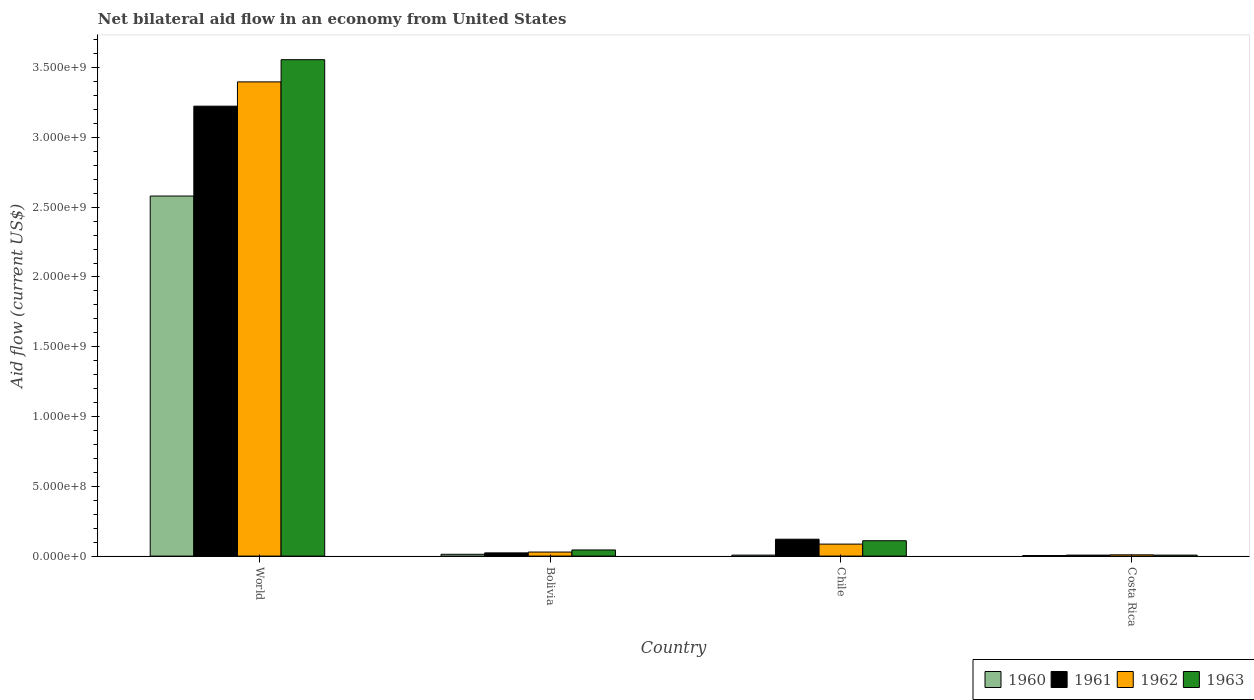How many groups of bars are there?
Provide a short and direct response. 4. Are the number of bars per tick equal to the number of legend labels?
Your response must be concise. Yes. How many bars are there on the 2nd tick from the left?
Your response must be concise. 4. How many bars are there on the 4th tick from the right?
Offer a terse response. 4. What is the net bilateral aid flow in 1960 in World?
Keep it short and to the point. 2.58e+09. Across all countries, what is the maximum net bilateral aid flow in 1960?
Provide a succinct answer. 2.58e+09. Across all countries, what is the minimum net bilateral aid flow in 1960?
Give a very brief answer. 4.00e+06. In which country was the net bilateral aid flow in 1963 maximum?
Keep it short and to the point. World. In which country was the net bilateral aid flow in 1963 minimum?
Your response must be concise. Costa Rica. What is the total net bilateral aid flow in 1961 in the graph?
Give a very brief answer. 3.38e+09. What is the difference between the net bilateral aid flow in 1963 in Bolivia and that in Chile?
Ensure brevity in your answer.  -6.60e+07. What is the difference between the net bilateral aid flow in 1960 in Bolivia and the net bilateral aid flow in 1962 in World?
Your answer should be very brief. -3.38e+09. What is the average net bilateral aid flow in 1961 per country?
Your response must be concise. 8.44e+08. What is the difference between the net bilateral aid flow of/in 1960 and net bilateral aid flow of/in 1961 in Bolivia?
Make the answer very short. -1.00e+07. In how many countries, is the net bilateral aid flow in 1960 greater than 400000000 US$?
Make the answer very short. 1. What is the ratio of the net bilateral aid flow in 1962 in Bolivia to that in World?
Give a very brief answer. 0.01. Is the difference between the net bilateral aid flow in 1960 in Costa Rica and World greater than the difference between the net bilateral aid flow in 1961 in Costa Rica and World?
Your answer should be very brief. Yes. What is the difference between the highest and the second highest net bilateral aid flow in 1960?
Offer a very short reply. 2.57e+09. What is the difference between the highest and the lowest net bilateral aid flow in 1962?
Offer a very short reply. 3.39e+09. How many bars are there?
Offer a very short reply. 16. Are all the bars in the graph horizontal?
Make the answer very short. No. How many countries are there in the graph?
Make the answer very short. 4. Does the graph contain any zero values?
Make the answer very short. No. What is the title of the graph?
Offer a very short reply. Net bilateral aid flow in an economy from United States. Does "1965" appear as one of the legend labels in the graph?
Keep it short and to the point. No. What is the label or title of the Y-axis?
Keep it short and to the point. Aid flow (current US$). What is the Aid flow (current US$) of 1960 in World?
Offer a terse response. 2.58e+09. What is the Aid flow (current US$) in 1961 in World?
Your answer should be very brief. 3.22e+09. What is the Aid flow (current US$) in 1962 in World?
Give a very brief answer. 3.40e+09. What is the Aid flow (current US$) in 1963 in World?
Keep it short and to the point. 3.56e+09. What is the Aid flow (current US$) of 1960 in Bolivia?
Your response must be concise. 1.30e+07. What is the Aid flow (current US$) in 1961 in Bolivia?
Your answer should be compact. 2.30e+07. What is the Aid flow (current US$) in 1962 in Bolivia?
Your answer should be very brief. 2.90e+07. What is the Aid flow (current US$) of 1963 in Bolivia?
Offer a terse response. 4.40e+07. What is the Aid flow (current US$) of 1960 in Chile?
Make the answer very short. 7.00e+06. What is the Aid flow (current US$) in 1961 in Chile?
Your answer should be compact. 1.21e+08. What is the Aid flow (current US$) in 1962 in Chile?
Your answer should be compact. 8.60e+07. What is the Aid flow (current US$) of 1963 in Chile?
Your answer should be very brief. 1.10e+08. What is the Aid flow (current US$) of 1961 in Costa Rica?
Your response must be concise. 7.00e+06. What is the Aid flow (current US$) of 1962 in Costa Rica?
Your answer should be very brief. 9.00e+06. What is the Aid flow (current US$) of 1963 in Costa Rica?
Ensure brevity in your answer.  7.00e+06. Across all countries, what is the maximum Aid flow (current US$) of 1960?
Keep it short and to the point. 2.58e+09. Across all countries, what is the maximum Aid flow (current US$) in 1961?
Make the answer very short. 3.22e+09. Across all countries, what is the maximum Aid flow (current US$) of 1962?
Your answer should be very brief. 3.40e+09. Across all countries, what is the maximum Aid flow (current US$) of 1963?
Make the answer very short. 3.56e+09. Across all countries, what is the minimum Aid flow (current US$) in 1960?
Give a very brief answer. 4.00e+06. Across all countries, what is the minimum Aid flow (current US$) of 1961?
Give a very brief answer. 7.00e+06. Across all countries, what is the minimum Aid flow (current US$) of 1962?
Give a very brief answer. 9.00e+06. Across all countries, what is the minimum Aid flow (current US$) in 1963?
Ensure brevity in your answer.  7.00e+06. What is the total Aid flow (current US$) in 1960 in the graph?
Ensure brevity in your answer.  2.60e+09. What is the total Aid flow (current US$) of 1961 in the graph?
Give a very brief answer. 3.38e+09. What is the total Aid flow (current US$) of 1962 in the graph?
Keep it short and to the point. 3.52e+09. What is the total Aid flow (current US$) in 1963 in the graph?
Your answer should be compact. 3.72e+09. What is the difference between the Aid flow (current US$) of 1960 in World and that in Bolivia?
Make the answer very short. 2.57e+09. What is the difference between the Aid flow (current US$) in 1961 in World and that in Bolivia?
Offer a very short reply. 3.20e+09. What is the difference between the Aid flow (current US$) in 1962 in World and that in Bolivia?
Your answer should be compact. 3.37e+09. What is the difference between the Aid flow (current US$) of 1963 in World and that in Bolivia?
Your response must be concise. 3.51e+09. What is the difference between the Aid flow (current US$) in 1960 in World and that in Chile?
Ensure brevity in your answer.  2.57e+09. What is the difference between the Aid flow (current US$) in 1961 in World and that in Chile?
Keep it short and to the point. 3.10e+09. What is the difference between the Aid flow (current US$) in 1962 in World and that in Chile?
Give a very brief answer. 3.31e+09. What is the difference between the Aid flow (current US$) in 1963 in World and that in Chile?
Offer a terse response. 3.45e+09. What is the difference between the Aid flow (current US$) in 1960 in World and that in Costa Rica?
Provide a short and direct response. 2.58e+09. What is the difference between the Aid flow (current US$) of 1961 in World and that in Costa Rica?
Your answer should be very brief. 3.22e+09. What is the difference between the Aid flow (current US$) of 1962 in World and that in Costa Rica?
Provide a short and direct response. 3.39e+09. What is the difference between the Aid flow (current US$) of 1963 in World and that in Costa Rica?
Ensure brevity in your answer.  3.55e+09. What is the difference between the Aid flow (current US$) of 1960 in Bolivia and that in Chile?
Provide a short and direct response. 6.00e+06. What is the difference between the Aid flow (current US$) of 1961 in Bolivia and that in Chile?
Provide a succinct answer. -9.80e+07. What is the difference between the Aid flow (current US$) in 1962 in Bolivia and that in Chile?
Provide a short and direct response. -5.70e+07. What is the difference between the Aid flow (current US$) in 1963 in Bolivia and that in Chile?
Provide a succinct answer. -6.60e+07. What is the difference between the Aid flow (current US$) in 1960 in Bolivia and that in Costa Rica?
Your response must be concise. 9.00e+06. What is the difference between the Aid flow (current US$) in 1961 in Bolivia and that in Costa Rica?
Provide a short and direct response. 1.60e+07. What is the difference between the Aid flow (current US$) of 1962 in Bolivia and that in Costa Rica?
Provide a short and direct response. 2.00e+07. What is the difference between the Aid flow (current US$) of 1963 in Bolivia and that in Costa Rica?
Your answer should be compact. 3.70e+07. What is the difference between the Aid flow (current US$) of 1960 in Chile and that in Costa Rica?
Make the answer very short. 3.00e+06. What is the difference between the Aid flow (current US$) of 1961 in Chile and that in Costa Rica?
Ensure brevity in your answer.  1.14e+08. What is the difference between the Aid flow (current US$) of 1962 in Chile and that in Costa Rica?
Offer a very short reply. 7.70e+07. What is the difference between the Aid flow (current US$) in 1963 in Chile and that in Costa Rica?
Provide a succinct answer. 1.03e+08. What is the difference between the Aid flow (current US$) in 1960 in World and the Aid flow (current US$) in 1961 in Bolivia?
Ensure brevity in your answer.  2.56e+09. What is the difference between the Aid flow (current US$) in 1960 in World and the Aid flow (current US$) in 1962 in Bolivia?
Give a very brief answer. 2.55e+09. What is the difference between the Aid flow (current US$) in 1960 in World and the Aid flow (current US$) in 1963 in Bolivia?
Offer a very short reply. 2.54e+09. What is the difference between the Aid flow (current US$) in 1961 in World and the Aid flow (current US$) in 1962 in Bolivia?
Make the answer very short. 3.20e+09. What is the difference between the Aid flow (current US$) of 1961 in World and the Aid flow (current US$) of 1963 in Bolivia?
Ensure brevity in your answer.  3.18e+09. What is the difference between the Aid flow (current US$) in 1962 in World and the Aid flow (current US$) in 1963 in Bolivia?
Keep it short and to the point. 3.35e+09. What is the difference between the Aid flow (current US$) of 1960 in World and the Aid flow (current US$) of 1961 in Chile?
Keep it short and to the point. 2.46e+09. What is the difference between the Aid flow (current US$) of 1960 in World and the Aid flow (current US$) of 1962 in Chile?
Provide a succinct answer. 2.49e+09. What is the difference between the Aid flow (current US$) of 1960 in World and the Aid flow (current US$) of 1963 in Chile?
Provide a succinct answer. 2.47e+09. What is the difference between the Aid flow (current US$) of 1961 in World and the Aid flow (current US$) of 1962 in Chile?
Give a very brief answer. 3.14e+09. What is the difference between the Aid flow (current US$) in 1961 in World and the Aid flow (current US$) in 1963 in Chile?
Your answer should be very brief. 3.11e+09. What is the difference between the Aid flow (current US$) in 1962 in World and the Aid flow (current US$) in 1963 in Chile?
Provide a short and direct response. 3.29e+09. What is the difference between the Aid flow (current US$) of 1960 in World and the Aid flow (current US$) of 1961 in Costa Rica?
Ensure brevity in your answer.  2.57e+09. What is the difference between the Aid flow (current US$) of 1960 in World and the Aid flow (current US$) of 1962 in Costa Rica?
Your response must be concise. 2.57e+09. What is the difference between the Aid flow (current US$) in 1960 in World and the Aid flow (current US$) in 1963 in Costa Rica?
Ensure brevity in your answer.  2.57e+09. What is the difference between the Aid flow (current US$) of 1961 in World and the Aid flow (current US$) of 1962 in Costa Rica?
Provide a succinct answer. 3.22e+09. What is the difference between the Aid flow (current US$) of 1961 in World and the Aid flow (current US$) of 1963 in Costa Rica?
Your answer should be very brief. 3.22e+09. What is the difference between the Aid flow (current US$) in 1962 in World and the Aid flow (current US$) in 1963 in Costa Rica?
Offer a very short reply. 3.39e+09. What is the difference between the Aid flow (current US$) in 1960 in Bolivia and the Aid flow (current US$) in 1961 in Chile?
Your answer should be compact. -1.08e+08. What is the difference between the Aid flow (current US$) of 1960 in Bolivia and the Aid flow (current US$) of 1962 in Chile?
Offer a terse response. -7.30e+07. What is the difference between the Aid flow (current US$) of 1960 in Bolivia and the Aid flow (current US$) of 1963 in Chile?
Offer a terse response. -9.70e+07. What is the difference between the Aid flow (current US$) in 1961 in Bolivia and the Aid flow (current US$) in 1962 in Chile?
Keep it short and to the point. -6.30e+07. What is the difference between the Aid flow (current US$) of 1961 in Bolivia and the Aid flow (current US$) of 1963 in Chile?
Your answer should be very brief. -8.70e+07. What is the difference between the Aid flow (current US$) of 1962 in Bolivia and the Aid flow (current US$) of 1963 in Chile?
Your response must be concise. -8.10e+07. What is the difference between the Aid flow (current US$) of 1961 in Bolivia and the Aid flow (current US$) of 1962 in Costa Rica?
Give a very brief answer. 1.40e+07. What is the difference between the Aid flow (current US$) of 1961 in Bolivia and the Aid flow (current US$) of 1963 in Costa Rica?
Make the answer very short. 1.60e+07. What is the difference between the Aid flow (current US$) of 1962 in Bolivia and the Aid flow (current US$) of 1963 in Costa Rica?
Provide a succinct answer. 2.20e+07. What is the difference between the Aid flow (current US$) of 1960 in Chile and the Aid flow (current US$) of 1962 in Costa Rica?
Provide a succinct answer. -2.00e+06. What is the difference between the Aid flow (current US$) in 1961 in Chile and the Aid flow (current US$) in 1962 in Costa Rica?
Offer a terse response. 1.12e+08. What is the difference between the Aid flow (current US$) in 1961 in Chile and the Aid flow (current US$) in 1963 in Costa Rica?
Provide a succinct answer. 1.14e+08. What is the difference between the Aid flow (current US$) in 1962 in Chile and the Aid flow (current US$) in 1963 in Costa Rica?
Your response must be concise. 7.90e+07. What is the average Aid flow (current US$) of 1960 per country?
Ensure brevity in your answer.  6.51e+08. What is the average Aid flow (current US$) in 1961 per country?
Give a very brief answer. 8.44e+08. What is the average Aid flow (current US$) of 1962 per country?
Your answer should be very brief. 8.80e+08. What is the average Aid flow (current US$) in 1963 per country?
Make the answer very short. 9.30e+08. What is the difference between the Aid flow (current US$) of 1960 and Aid flow (current US$) of 1961 in World?
Your response must be concise. -6.44e+08. What is the difference between the Aid flow (current US$) of 1960 and Aid flow (current US$) of 1962 in World?
Provide a short and direct response. -8.18e+08. What is the difference between the Aid flow (current US$) of 1960 and Aid flow (current US$) of 1963 in World?
Give a very brief answer. -9.77e+08. What is the difference between the Aid flow (current US$) in 1961 and Aid flow (current US$) in 1962 in World?
Offer a very short reply. -1.74e+08. What is the difference between the Aid flow (current US$) in 1961 and Aid flow (current US$) in 1963 in World?
Provide a short and direct response. -3.33e+08. What is the difference between the Aid flow (current US$) in 1962 and Aid flow (current US$) in 1963 in World?
Your answer should be compact. -1.59e+08. What is the difference between the Aid flow (current US$) of 1960 and Aid flow (current US$) of 1961 in Bolivia?
Make the answer very short. -1.00e+07. What is the difference between the Aid flow (current US$) in 1960 and Aid flow (current US$) in 1962 in Bolivia?
Give a very brief answer. -1.60e+07. What is the difference between the Aid flow (current US$) of 1960 and Aid flow (current US$) of 1963 in Bolivia?
Make the answer very short. -3.10e+07. What is the difference between the Aid flow (current US$) of 1961 and Aid flow (current US$) of 1962 in Bolivia?
Make the answer very short. -6.00e+06. What is the difference between the Aid flow (current US$) of 1961 and Aid flow (current US$) of 1963 in Bolivia?
Make the answer very short. -2.10e+07. What is the difference between the Aid flow (current US$) of 1962 and Aid flow (current US$) of 1963 in Bolivia?
Offer a very short reply. -1.50e+07. What is the difference between the Aid flow (current US$) of 1960 and Aid flow (current US$) of 1961 in Chile?
Your answer should be compact. -1.14e+08. What is the difference between the Aid flow (current US$) of 1960 and Aid flow (current US$) of 1962 in Chile?
Keep it short and to the point. -7.90e+07. What is the difference between the Aid flow (current US$) in 1960 and Aid flow (current US$) in 1963 in Chile?
Provide a succinct answer. -1.03e+08. What is the difference between the Aid flow (current US$) in 1961 and Aid flow (current US$) in 1962 in Chile?
Your answer should be very brief. 3.50e+07. What is the difference between the Aid flow (current US$) in 1961 and Aid flow (current US$) in 1963 in Chile?
Ensure brevity in your answer.  1.10e+07. What is the difference between the Aid flow (current US$) in 1962 and Aid flow (current US$) in 1963 in Chile?
Provide a succinct answer. -2.40e+07. What is the difference between the Aid flow (current US$) of 1960 and Aid flow (current US$) of 1961 in Costa Rica?
Your response must be concise. -3.00e+06. What is the difference between the Aid flow (current US$) in 1960 and Aid flow (current US$) in 1962 in Costa Rica?
Give a very brief answer. -5.00e+06. What is the difference between the Aid flow (current US$) of 1960 and Aid flow (current US$) of 1963 in Costa Rica?
Your answer should be very brief. -3.00e+06. What is the difference between the Aid flow (current US$) in 1961 and Aid flow (current US$) in 1963 in Costa Rica?
Give a very brief answer. 0. What is the ratio of the Aid flow (current US$) in 1960 in World to that in Bolivia?
Give a very brief answer. 198.46. What is the ratio of the Aid flow (current US$) of 1961 in World to that in Bolivia?
Your answer should be very brief. 140.17. What is the ratio of the Aid flow (current US$) of 1962 in World to that in Bolivia?
Ensure brevity in your answer.  117.17. What is the ratio of the Aid flow (current US$) of 1963 in World to that in Bolivia?
Give a very brief answer. 80.84. What is the ratio of the Aid flow (current US$) of 1960 in World to that in Chile?
Ensure brevity in your answer.  368.57. What is the ratio of the Aid flow (current US$) in 1961 in World to that in Chile?
Offer a very short reply. 26.64. What is the ratio of the Aid flow (current US$) in 1962 in World to that in Chile?
Keep it short and to the point. 39.51. What is the ratio of the Aid flow (current US$) in 1963 in World to that in Chile?
Make the answer very short. 32.34. What is the ratio of the Aid flow (current US$) in 1960 in World to that in Costa Rica?
Provide a succinct answer. 645. What is the ratio of the Aid flow (current US$) in 1961 in World to that in Costa Rica?
Give a very brief answer. 460.57. What is the ratio of the Aid flow (current US$) of 1962 in World to that in Costa Rica?
Offer a very short reply. 377.56. What is the ratio of the Aid flow (current US$) of 1963 in World to that in Costa Rica?
Offer a very short reply. 508.14. What is the ratio of the Aid flow (current US$) in 1960 in Bolivia to that in Chile?
Offer a terse response. 1.86. What is the ratio of the Aid flow (current US$) in 1961 in Bolivia to that in Chile?
Make the answer very short. 0.19. What is the ratio of the Aid flow (current US$) in 1962 in Bolivia to that in Chile?
Ensure brevity in your answer.  0.34. What is the ratio of the Aid flow (current US$) of 1963 in Bolivia to that in Chile?
Your response must be concise. 0.4. What is the ratio of the Aid flow (current US$) of 1961 in Bolivia to that in Costa Rica?
Ensure brevity in your answer.  3.29. What is the ratio of the Aid flow (current US$) in 1962 in Bolivia to that in Costa Rica?
Keep it short and to the point. 3.22. What is the ratio of the Aid flow (current US$) in 1963 in Bolivia to that in Costa Rica?
Keep it short and to the point. 6.29. What is the ratio of the Aid flow (current US$) of 1960 in Chile to that in Costa Rica?
Your answer should be compact. 1.75. What is the ratio of the Aid flow (current US$) of 1961 in Chile to that in Costa Rica?
Your answer should be very brief. 17.29. What is the ratio of the Aid flow (current US$) in 1962 in Chile to that in Costa Rica?
Your answer should be very brief. 9.56. What is the ratio of the Aid flow (current US$) in 1963 in Chile to that in Costa Rica?
Provide a short and direct response. 15.71. What is the difference between the highest and the second highest Aid flow (current US$) in 1960?
Your answer should be very brief. 2.57e+09. What is the difference between the highest and the second highest Aid flow (current US$) of 1961?
Provide a succinct answer. 3.10e+09. What is the difference between the highest and the second highest Aid flow (current US$) of 1962?
Your answer should be very brief. 3.31e+09. What is the difference between the highest and the second highest Aid flow (current US$) in 1963?
Ensure brevity in your answer.  3.45e+09. What is the difference between the highest and the lowest Aid flow (current US$) in 1960?
Your answer should be very brief. 2.58e+09. What is the difference between the highest and the lowest Aid flow (current US$) of 1961?
Your response must be concise. 3.22e+09. What is the difference between the highest and the lowest Aid flow (current US$) of 1962?
Keep it short and to the point. 3.39e+09. What is the difference between the highest and the lowest Aid flow (current US$) in 1963?
Your answer should be very brief. 3.55e+09. 